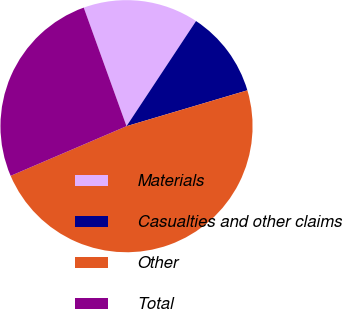Convert chart to OTSL. <chart><loc_0><loc_0><loc_500><loc_500><pie_chart><fcel>Materials<fcel>Casualties and other claims<fcel>Other<fcel>Total<nl><fcel>14.81%<fcel>11.11%<fcel>48.15%<fcel>25.93%<nl></chart> 